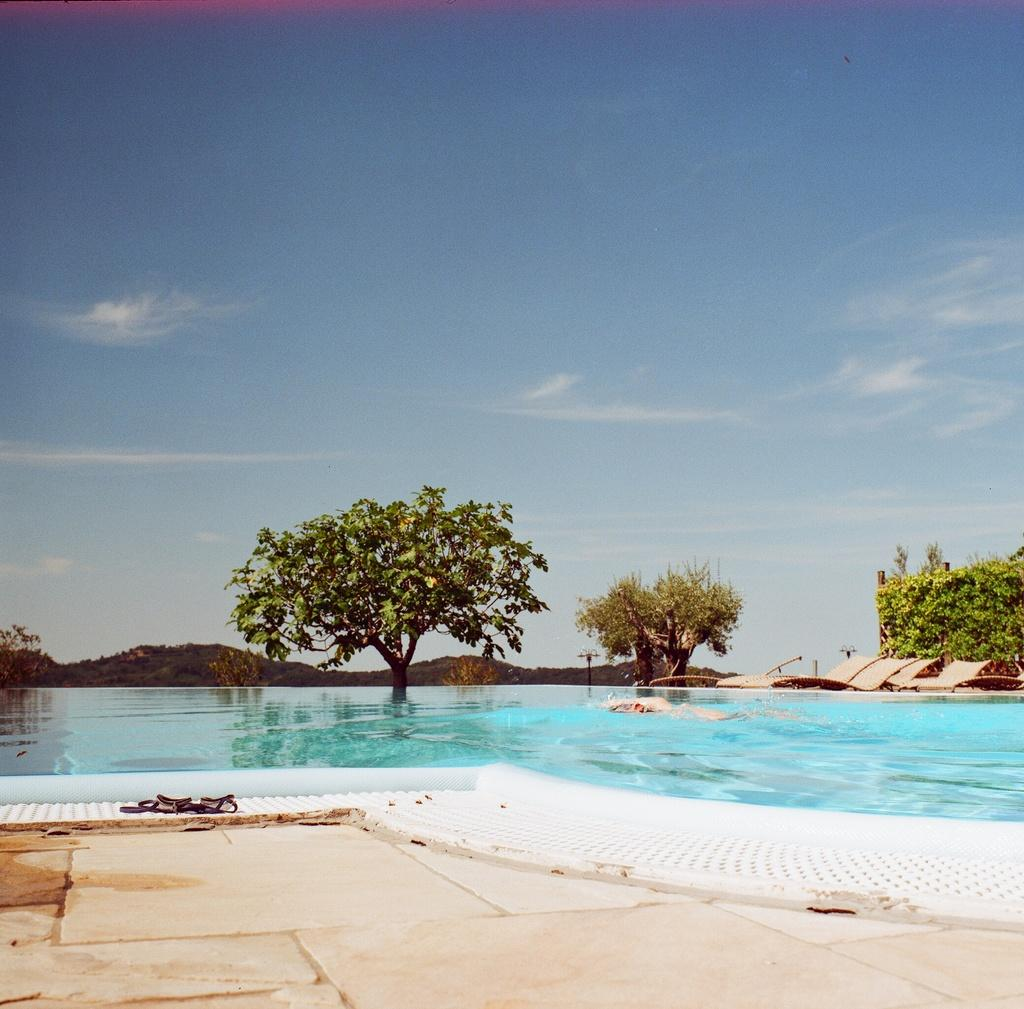What is the person in the image doing? There is a person swimming in a pool in the image. What type of seating is available in the image? There are benches in the image. What type of vegetation can be seen in the image? There is a group of trees in the image. What type of structures are present in the image? There are poles in the image. What type of landscape can be seen in the image? The hills are visible in the image. What is the weather like in the image? The sky is cloudy in the image. What type of pollution can be seen in the image? There is no pollution visible in the image. Who owns the property in the image? There is no indication of property ownership in the image. 